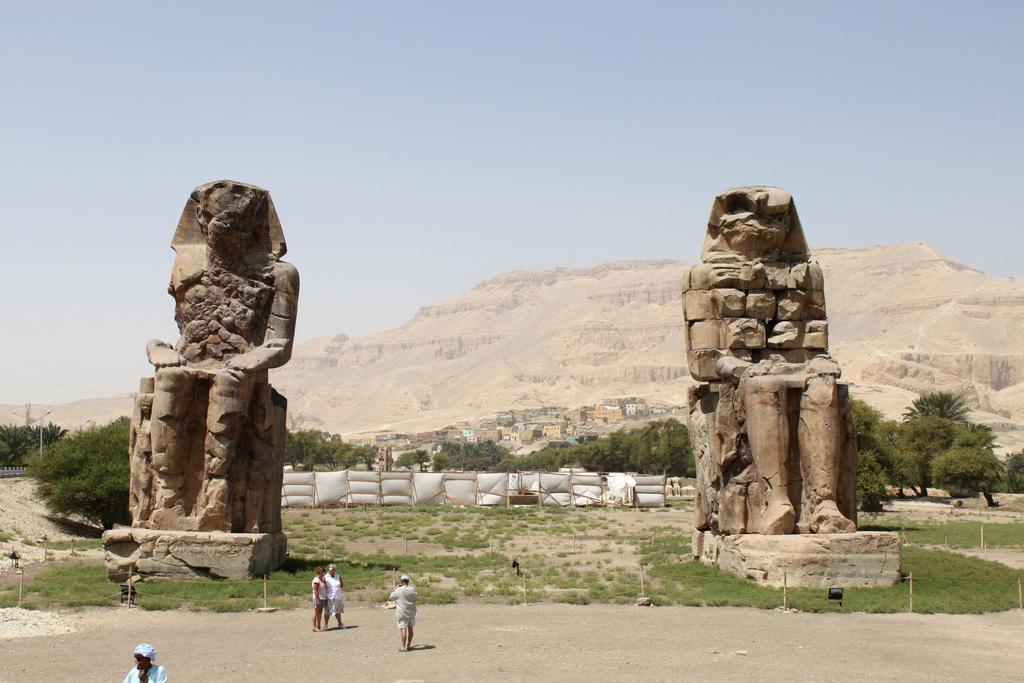Please provide a concise description of this image. In this image we can see sky, pyramids, sculptures, trees, ground, grass and poles. 